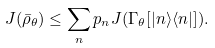<formula> <loc_0><loc_0><loc_500><loc_500>J ( \bar { \rho } _ { \theta } ) \leq \sum _ { n } p _ { n } J ( \Gamma _ { \theta } [ | n \rangle \langle n | ] ) .</formula> 